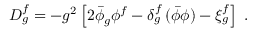<formula> <loc_0><loc_0><loc_500><loc_500>D _ { g } ^ { f } = - g ^ { 2 } \left [ 2 \bar { \phi } _ { g } \phi ^ { f } - \delta _ { g } ^ { f } \, ( \bar { \phi } \phi ) - \xi _ { g } ^ { f } \right ] \, .</formula> 